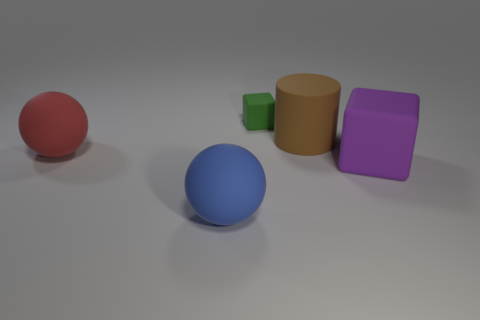The blue object has what size?
Provide a succinct answer. Large. What number of tiny things are either yellow matte objects or cylinders?
Provide a short and direct response. 0. What is the size of the object that is in front of the big red matte sphere and to the left of the big brown matte cylinder?
Give a very brief answer. Large. What number of large purple cubes are to the right of the tiny green cube?
Offer a terse response. 1. What shape is the large rubber thing that is both right of the small green object and on the left side of the large purple rubber block?
Offer a very short reply. Cylinder. What number of balls are blue matte objects or large brown objects?
Give a very brief answer. 1. Are there fewer large matte objects in front of the big purple rubber cube than spheres?
Provide a succinct answer. Yes. There is a big thing that is both on the right side of the red ball and left of the tiny block; what is its color?
Ensure brevity in your answer.  Blue. What number of other objects are there of the same shape as the big red thing?
Your answer should be very brief. 1. Is the number of brown rubber cylinders that are on the left side of the tiny block less than the number of brown objects in front of the large blue sphere?
Provide a short and direct response. No. 